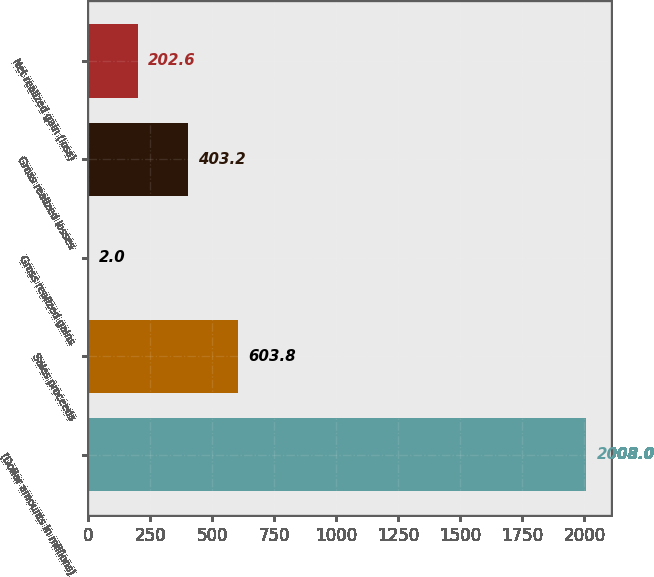<chart> <loc_0><loc_0><loc_500><loc_500><bar_chart><fcel>(Dollar amounts in millions)<fcel>Sales proceeds<fcel>Gross realized gains<fcel>Gross realized losses<fcel>Net realized gain (loss)<nl><fcel>2008<fcel>603.8<fcel>2<fcel>403.2<fcel>202.6<nl></chart> 